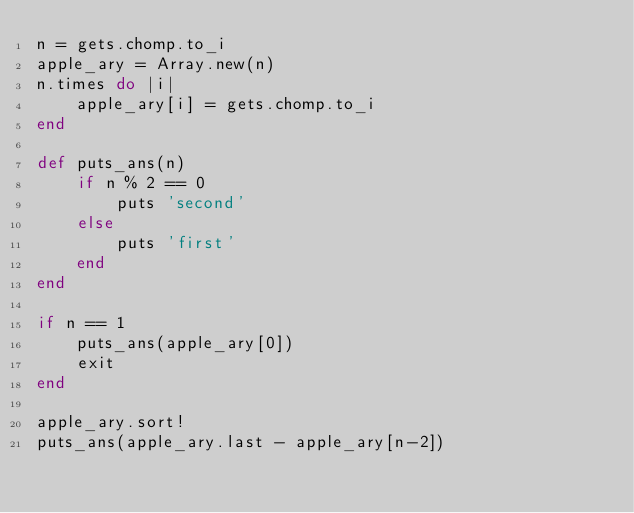<code> <loc_0><loc_0><loc_500><loc_500><_Ruby_>n = gets.chomp.to_i
apple_ary = Array.new(n)
n.times do |i|
    apple_ary[i] = gets.chomp.to_i
end

def puts_ans(n)
    if n % 2 == 0
        puts 'second'
    else
        puts 'first'
    end
end

if n == 1
    puts_ans(apple_ary[0])
    exit
end

apple_ary.sort!
puts_ans(apple_ary.last - apple_ary[n-2])
</code> 